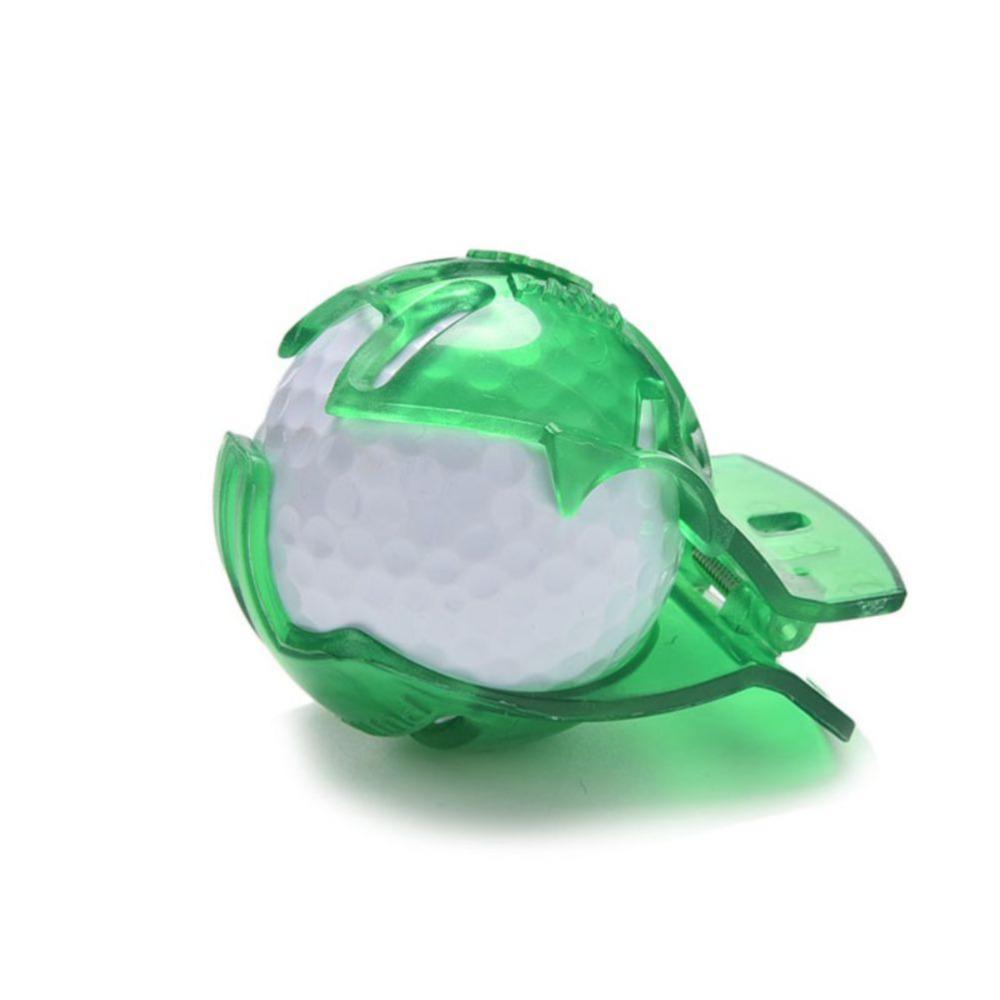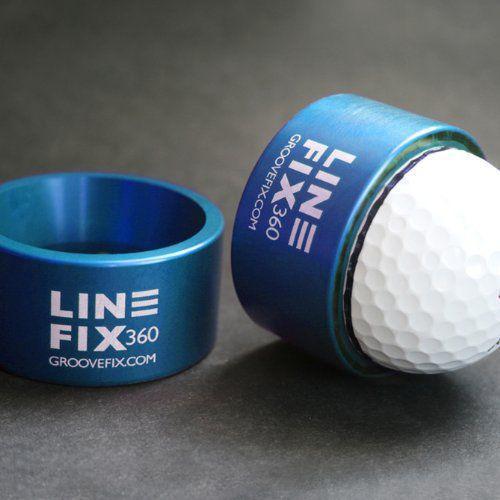The first image is the image on the left, the second image is the image on the right. Evaluate the accuracy of this statement regarding the images: "There are only two golf balls, and both of them are in translucent green containers.". Is it true? Answer yes or no. No. The first image is the image on the left, the second image is the image on the right. Assess this claim about the two images: "In one of the images there is a golf ball with red lines on it.". Correct or not? Answer yes or no. No. 